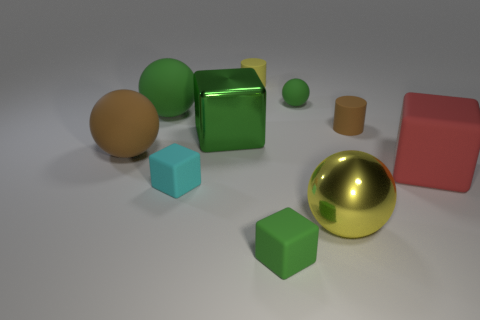There is a brown ball that is the same material as the cyan object; what is its size?
Your response must be concise. Large. What is the size of the brown matte cylinder?
Provide a succinct answer. Small. Are the small brown object and the cyan thing made of the same material?
Make the answer very short. Yes. What number of balls are either small red objects or cyan rubber things?
Your answer should be very brief. 0. What color is the block behind the red matte thing that is to the right of the tiny rubber ball?
Your answer should be compact. Green. What is the size of the other cube that is the same color as the large shiny cube?
Your answer should be compact. Small. What number of large yellow balls are on the right side of the brown ball that is behind the green block that is in front of the large green cube?
Your response must be concise. 1. Do the brown matte object behind the large green metal cube and the metal object in front of the large brown matte object have the same shape?
Ensure brevity in your answer.  No. What number of objects are small green balls or tiny brown things?
Keep it short and to the point. 2. The big sphere that is right of the small green thing behind the big red thing is made of what material?
Ensure brevity in your answer.  Metal. 